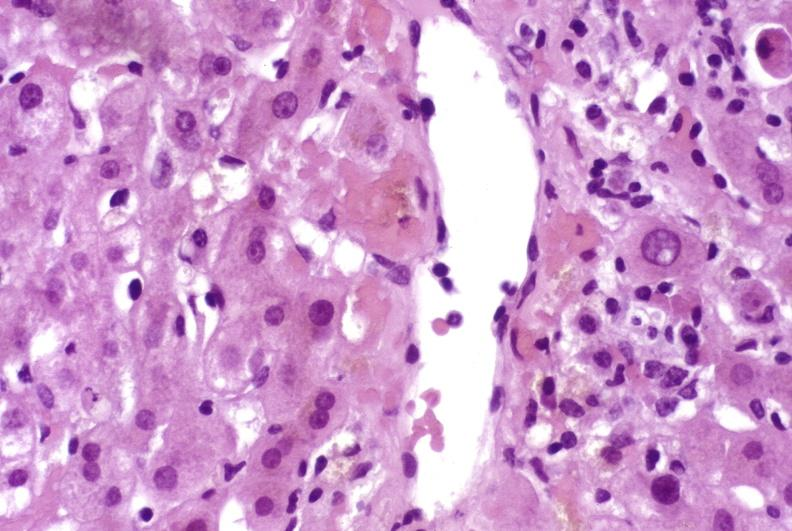s pinworm present?
Answer the question using a single word or phrase. No 